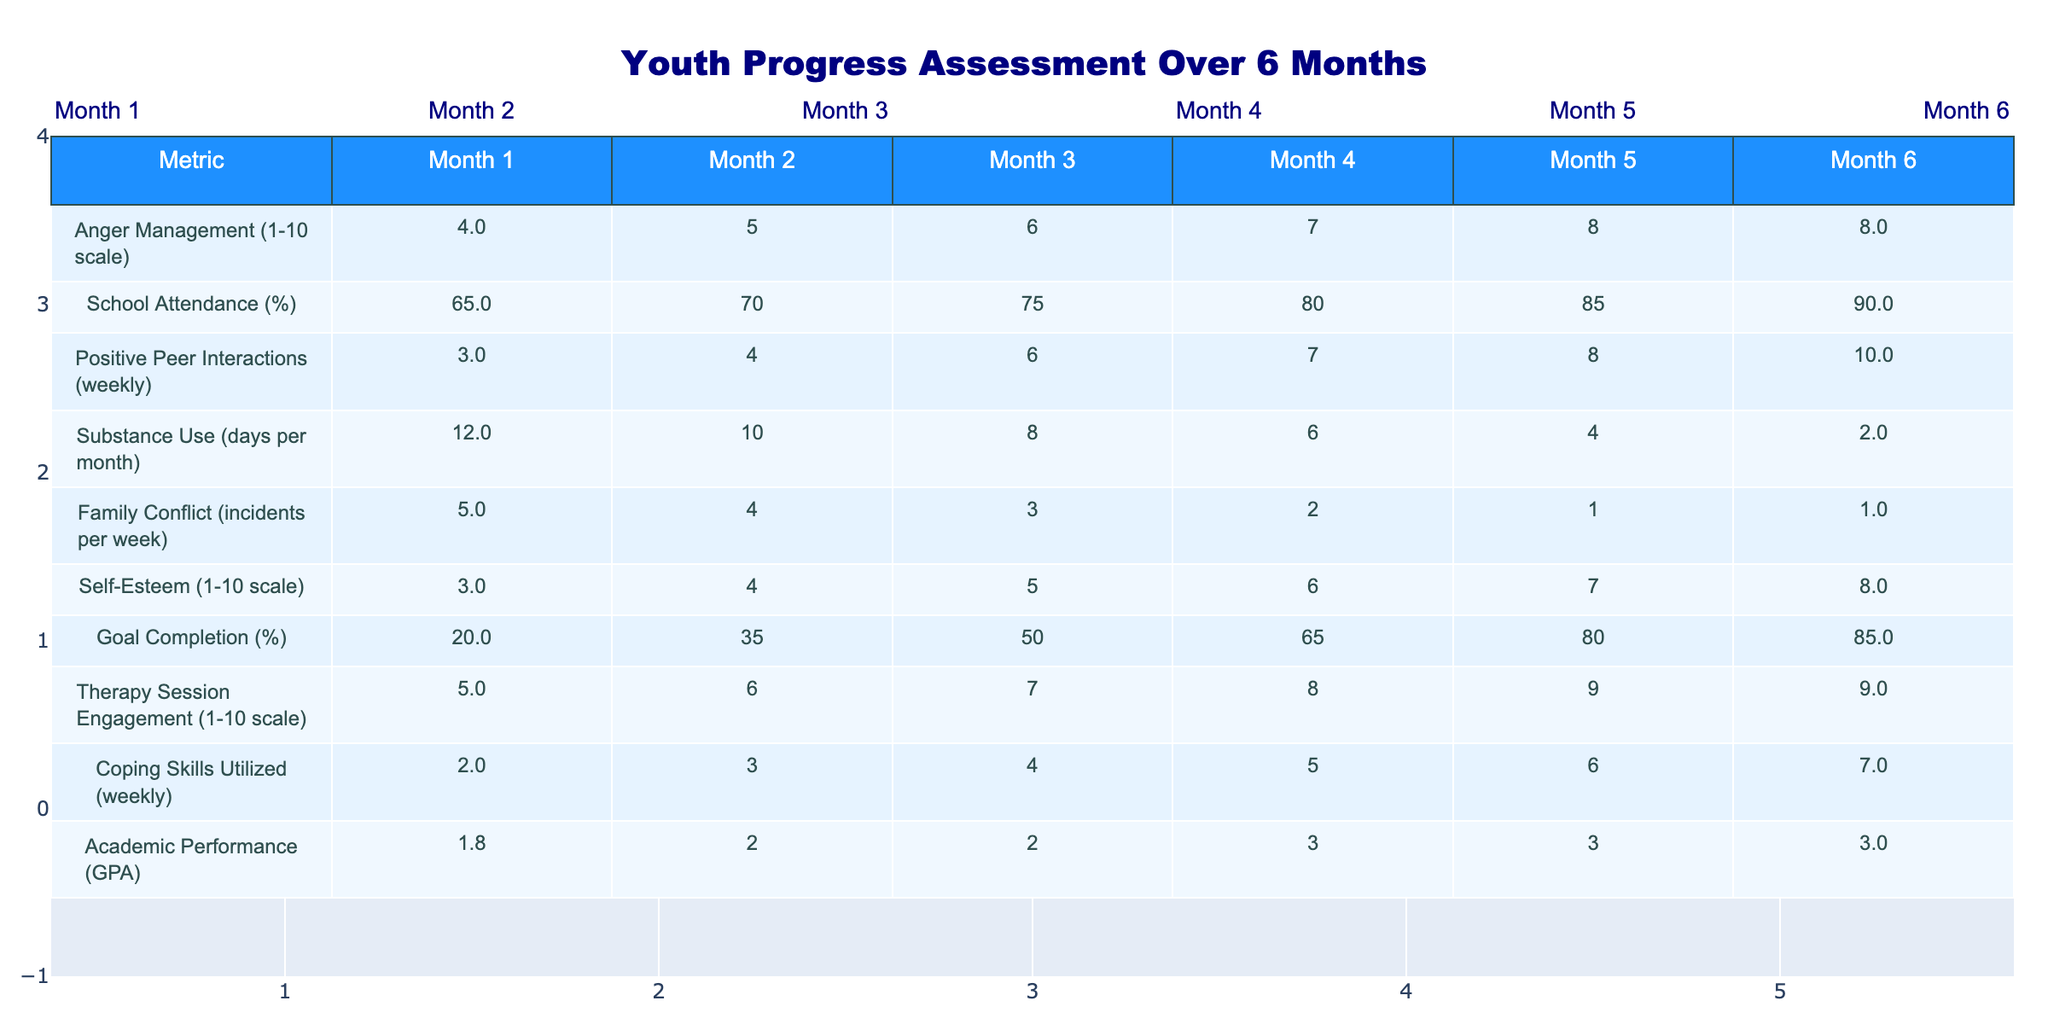What was the self-esteem score in Month 3? Referring to the table, the self-esteem score for Month 3 is listed in the corresponding row. It shows a value of 5.
Answer: 5 What is the percentage increase in school attendance from Month 1 to Month 6? School attendance in Month 1 is 65%, and in Month 6 it is 90%. The increase is calculated as (90 - 65) / 65 * 100 = 38.46%.
Answer: 38.46% In which month did positive peer interactions reach the highest value? Looking at the positive peer interactions row, the highest value is 10, which occurs in Month 6.
Answer: Month 6 Was the anger management score consistent throughout the six-month period? The anger management scores show a consistent increase, starting at 4 and rising to 8 by Month 6, indicating they were not consistent.
Answer: No What is the average number of days for substance use over the six months? The substance use data points are 12, 10, 8, 6, 4, and 2. Their sum is 42, and dividing by 6 gives an average of 7.
Answer: 7 How did family conflict incidents change from Month 1 to Month 6? The family conflict decreased from 5 incidents in Month 1 to 1 incident in Month 6, showing a notable decline.
Answer: Decreased What was the overall trend for therapy session engagement scores throughout the six months? The engagement scores increased from 5 in Month 1 to 9 in Month 5 and held steady at 9 in Month 6, indicating a positive trend.
Answer: Increasing How many positive peer interactions were reported in Month 4? The table shows that there were 7 positive peer interactions reported in Month 4.
Answer: 7 If the goals completed in Month 6 were 85%, what were the goals completed in Month 2? Referring to the table, the goals completed in Month 2 were recorded as 35%.
Answer: 35% Which month saw the greatest improvement in academic performance? The academic performance values are 1.8, 2.0, 2.3, 2.6, 2.8, and 3.0. The greatest improvement occurred from Month 5 (2.8) to Month 6 (3.0), which is an increase of 0.2.
Answer: Month 5 to Month 6 What pattern can be observed in coping skills utilized over the six-month period? The number of coping skills utilized increased steadily from 2 in Month 1 to 7 in Month 6, showing a positive pattern.
Answer: Increasing pattern 